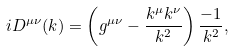Convert formula to latex. <formula><loc_0><loc_0><loc_500><loc_500>i D ^ { \mu \nu } ( k ) = \left ( g ^ { \mu \nu } - \frac { k ^ { \mu } k ^ { \nu } } { k ^ { 2 } } \right ) \frac { - 1 } { k ^ { 2 } } ,</formula> 